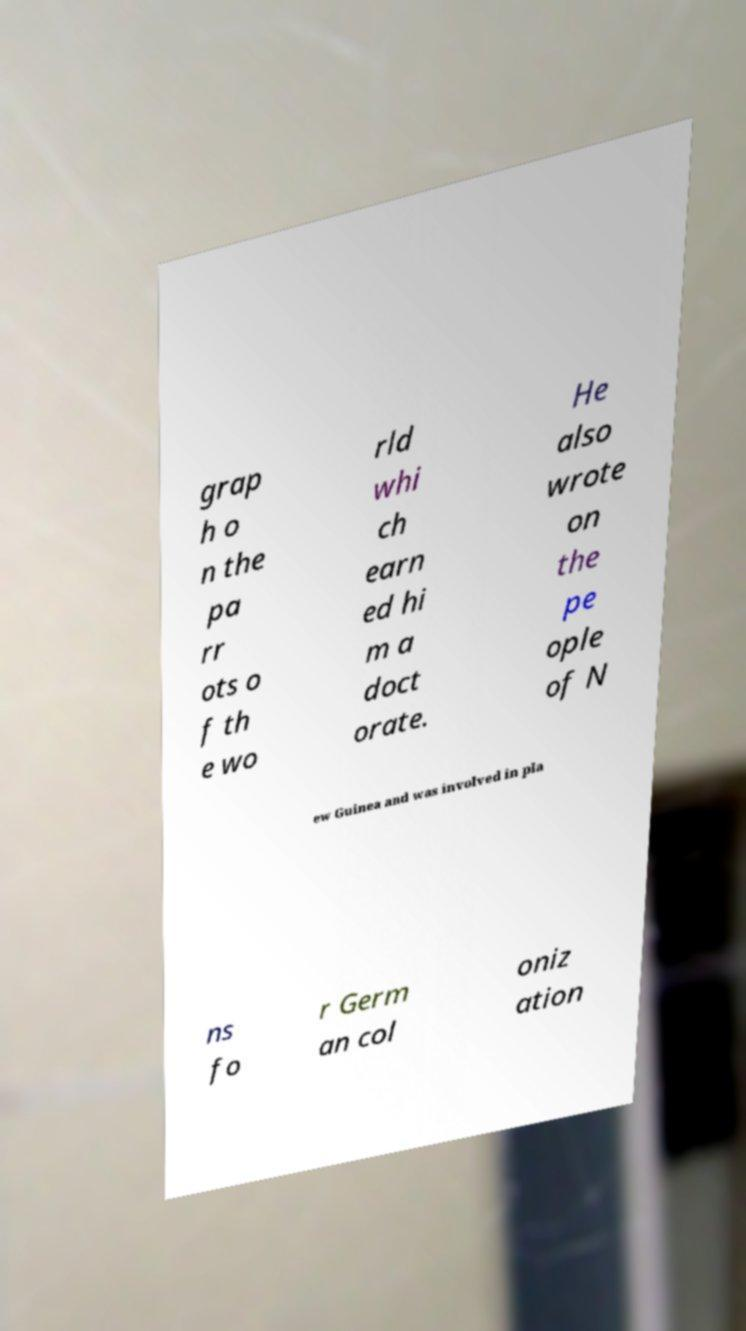Could you extract and type out the text from this image? grap h o n the pa rr ots o f th e wo rld whi ch earn ed hi m a doct orate. He also wrote on the pe ople of N ew Guinea and was involved in pla ns fo r Germ an col oniz ation 